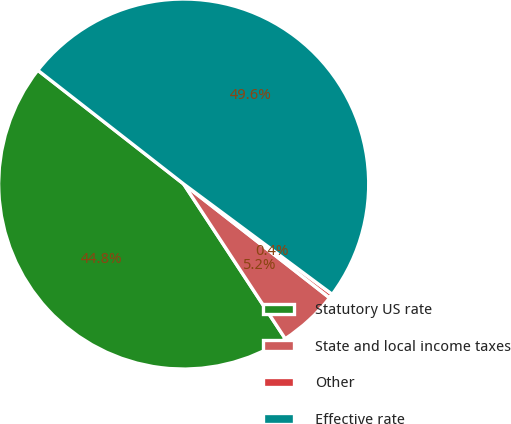<chart> <loc_0><loc_0><loc_500><loc_500><pie_chart><fcel>Statutory US rate<fcel>State and local income taxes<fcel>Other<fcel>Effective rate<nl><fcel>44.79%<fcel>5.21%<fcel>0.38%<fcel>49.62%<nl></chart> 